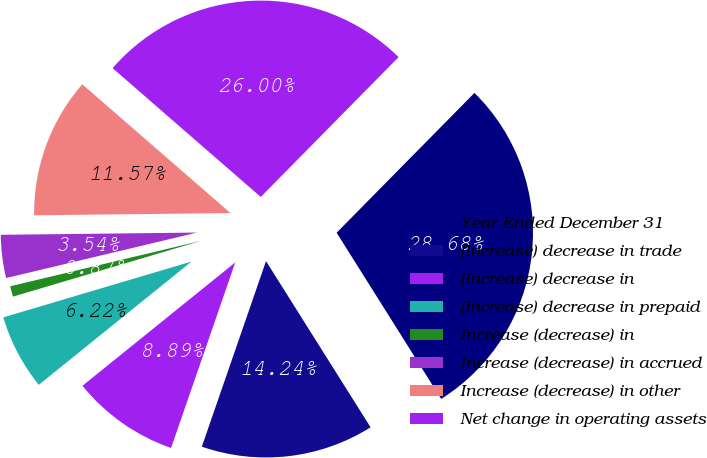<chart> <loc_0><loc_0><loc_500><loc_500><pie_chart><fcel>Year Ended December 31<fcel>(Increase) decrease in trade<fcel>(Increase) decrease in<fcel>(Increase) decrease in prepaid<fcel>Increase (decrease) in<fcel>Increase (decrease) in accrued<fcel>Increase (decrease) in other<fcel>Net change in operating assets<nl><fcel>28.68%<fcel>14.24%<fcel>8.89%<fcel>6.22%<fcel>0.87%<fcel>3.54%<fcel>11.57%<fcel>26.0%<nl></chart> 